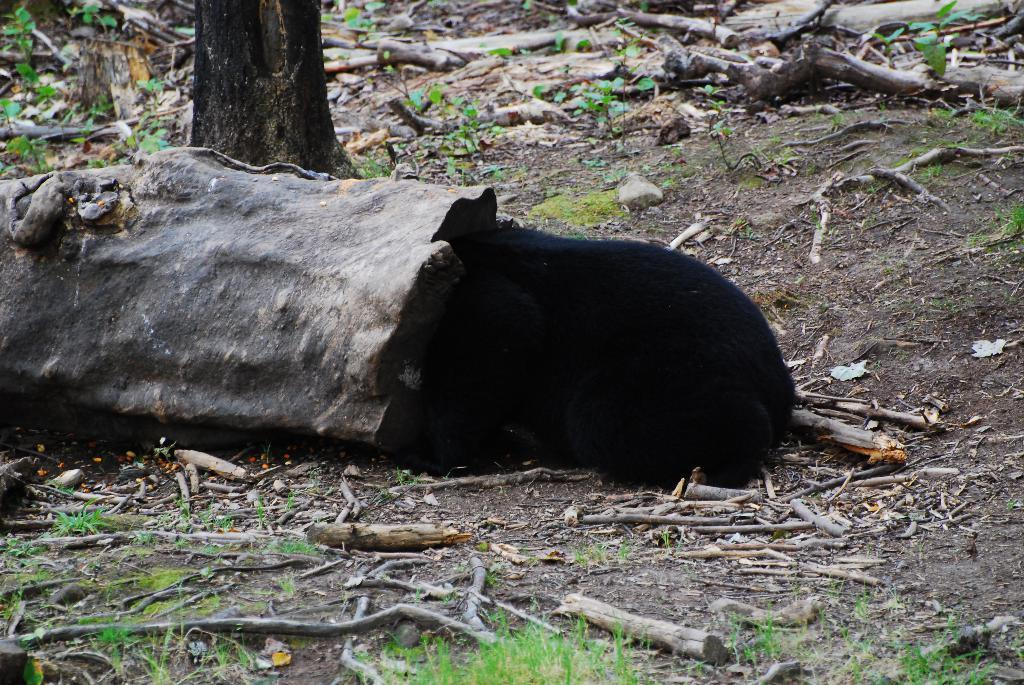What type of vegetation is present in the image? There is grass in the image. What else can be seen on the ground in the image? There are sticks on the ground in the image. What is the color of the black-colored object in the image? The black-colored object in the image is black. How much debt is represented by the orange in the image? There is no orange present in the image, and therefore no debt can be represented. What type of bread can be seen in the image? There is no bread present in the image. 